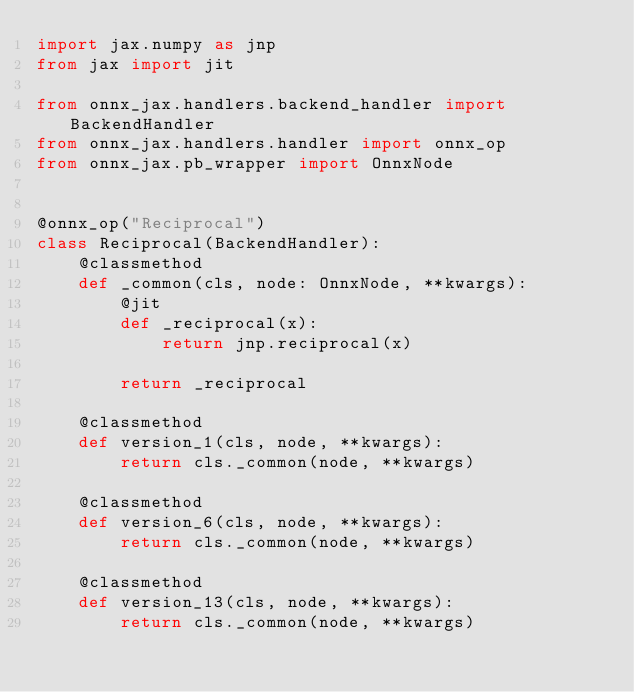<code> <loc_0><loc_0><loc_500><loc_500><_Python_>import jax.numpy as jnp
from jax import jit

from onnx_jax.handlers.backend_handler import BackendHandler
from onnx_jax.handlers.handler import onnx_op
from onnx_jax.pb_wrapper import OnnxNode


@onnx_op("Reciprocal")
class Reciprocal(BackendHandler):
    @classmethod
    def _common(cls, node: OnnxNode, **kwargs):
        @jit
        def _reciprocal(x):
            return jnp.reciprocal(x)

        return _reciprocal

    @classmethod
    def version_1(cls, node, **kwargs):
        return cls._common(node, **kwargs)

    @classmethod
    def version_6(cls, node, **kwargs):
        return cls._common(node, **kwargs)

    @classmethod
    def version_13(cls, node, **kwargs):
        return cls._common(node, **kwargs)
</code> 